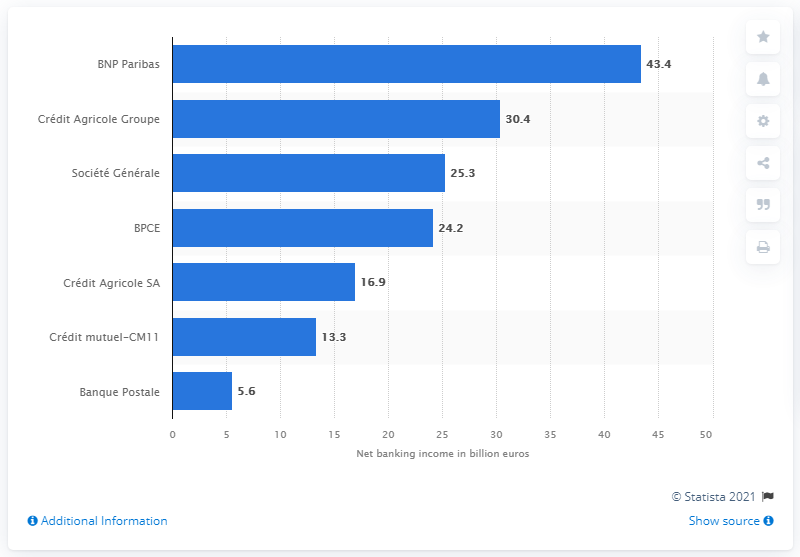Can you explain how BNP Paribas performed compared to other banks in 2016? In 2016, BNP Paribas had the highest net banking income among the listed banks at 43.4 billion euros, significantly outperforming others such as Crédit Agricole Groupe and Société Générale, which had 30.4 and 25.3 billion euros respectively. 